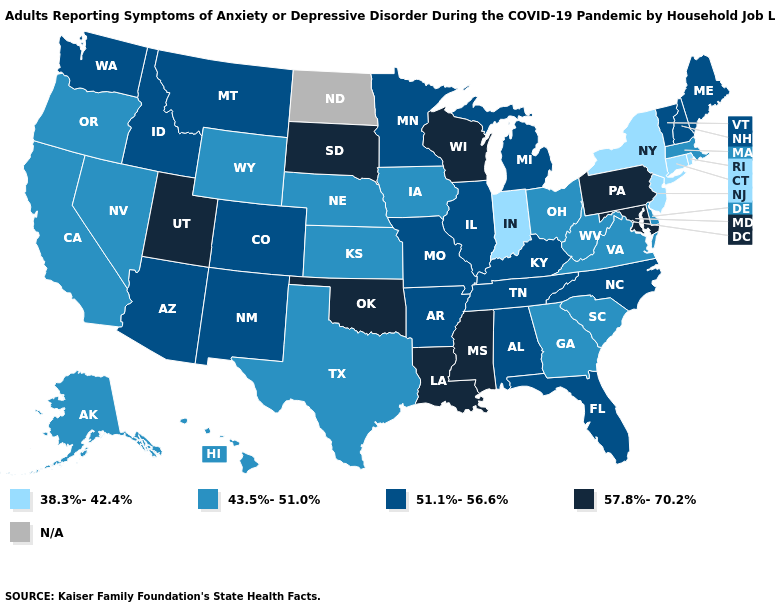Does the first symbol in the legend represent the smallest category?
Keep it brief. Yes. What is the value of Indiana?
Answer briefly. 38.3%-42.4%. Among the states that border Connecticut , does Rhode Island have the highest value?
Concise answer only. No. Name the states that have a value in the range N/A?
Short answer required. North Dakota. Does the map have missing data?
Concise answer only. Yes. Name the states that have a value in the range 51.1%-56.6%?
Concise answer only. Alabama, Arizona, Arkansas, Colorado, Florida, Idaho, Illinois, Kentucky, Maine, Michigan, Minnesota, Missouri, Montana, New Hampshire, New Mexico, North Carolina, Tennessee, Vermont, Washington. Does Nevada have the highest value in the USA?
Write a very short answer. No. What is the highest value in the West ?
Give a very brief answer. 57.8%-70.2%. Which states have the lowest value in the USA?
Answer briefly. Connecticut, Indiana, New Jersey, New York, Rhode Island. What is the lowest value in the USA?
Give a very brief answer. 38.3%-42.4%. Which states have the lowest value in the MidWest?
Keep it brief. Indiana. What is the lowest value in states that border Nevada?
Be succinct. 43.5%-51.0%. Does Alaska have the lowest value in the West?
Write a very short answer. Yes. Name the states that have a value in the range 38.3%-42.4%?
Answer briefly. Connecticut, Indiana, New Jersey, New York, Rhode Island. 